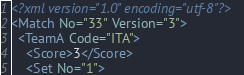Convert code to text. <code><loc_0><loc_0><loc_500><loc_500><_XML_><?xml version="1.0" encoding="utf-8"?>
<Match No="33" Version="3">
  <TeamA Code="ITA">
    <Score>3</Score>
    <Set No="1"></code> 